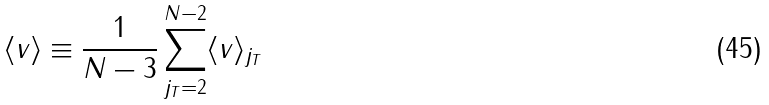Convert formula to latex. <formula><loc_0><loc_0><loc_500><loc_500>\langle v \rangle \equiv \frac { 1 } { N - 3 } \sum _ { j _ { T } = 2 } ^ { N - 2 } \langle v \rangle _ { j _ { T } }</formula> 